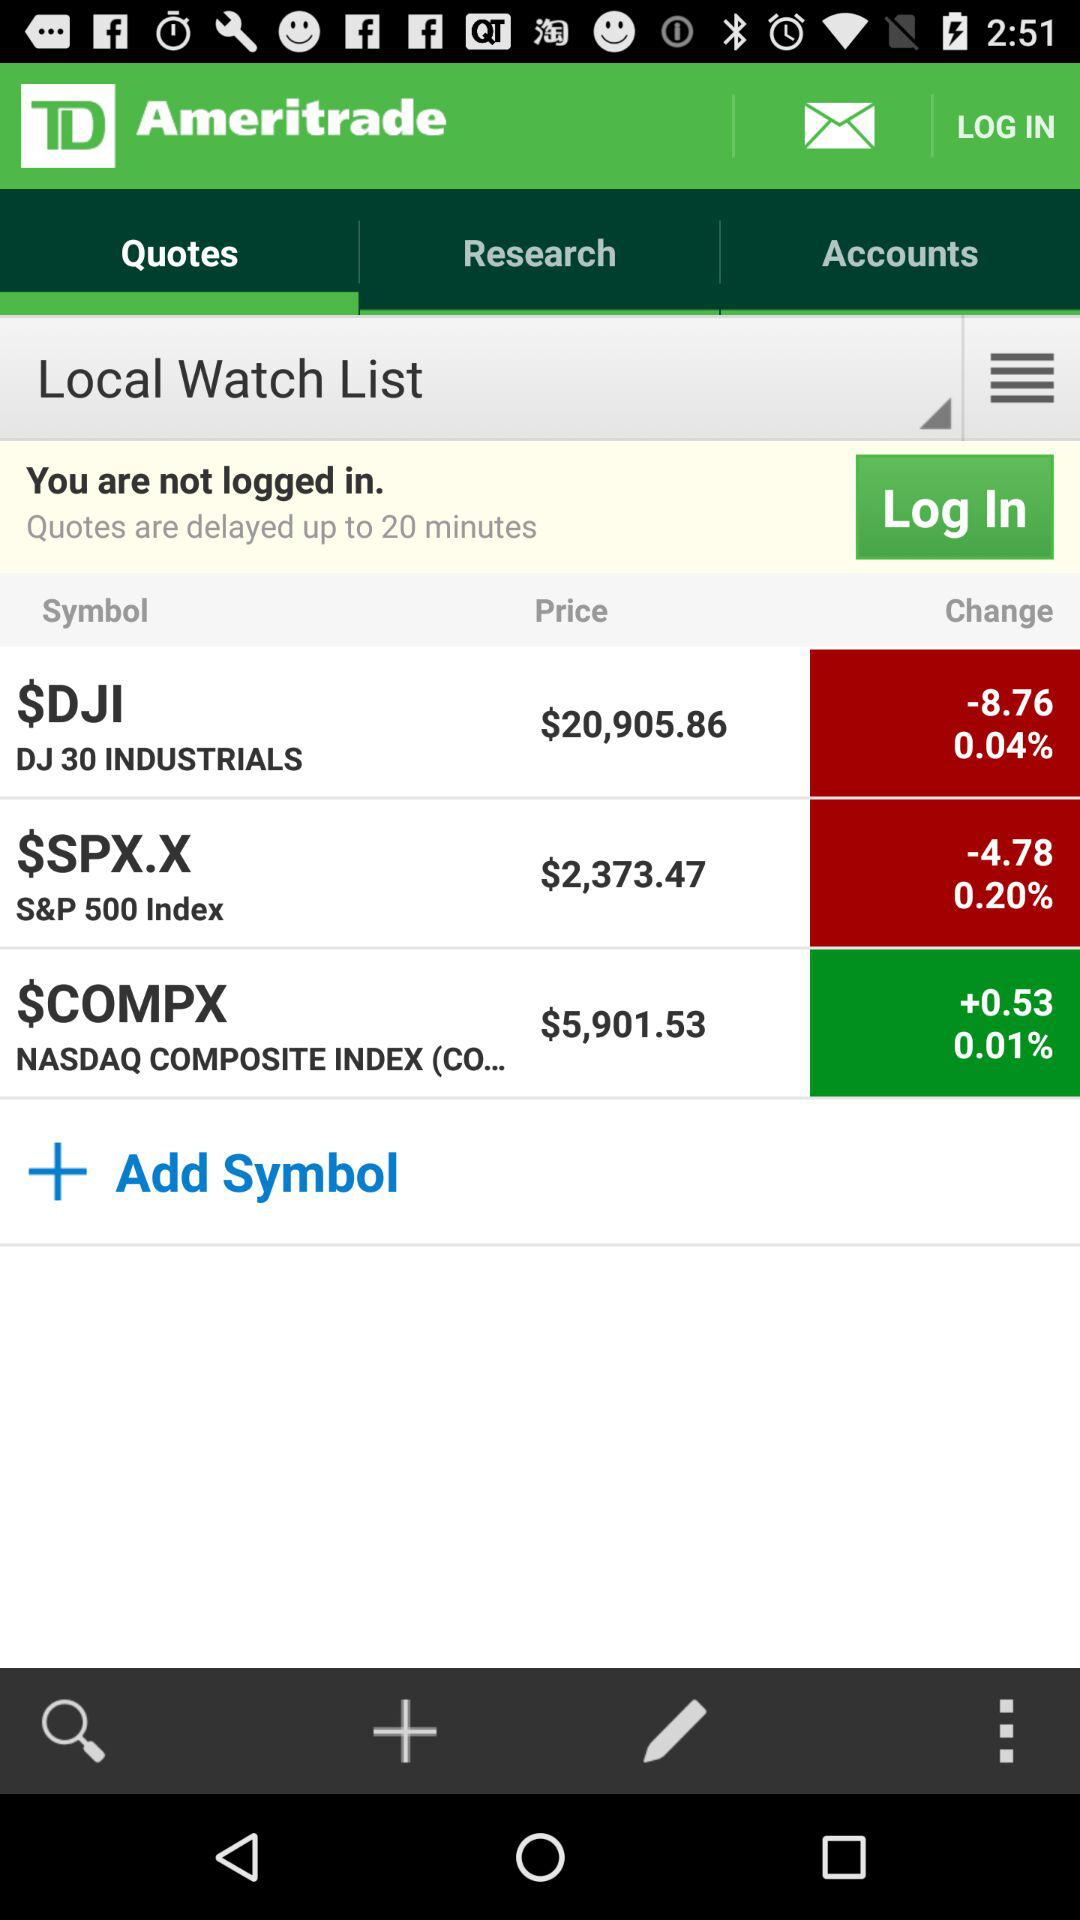What's the price of "DJ 30 INDUSTRIALS"? The price of "DJ 30 INDUSTRIALS" is $20,905.86. 